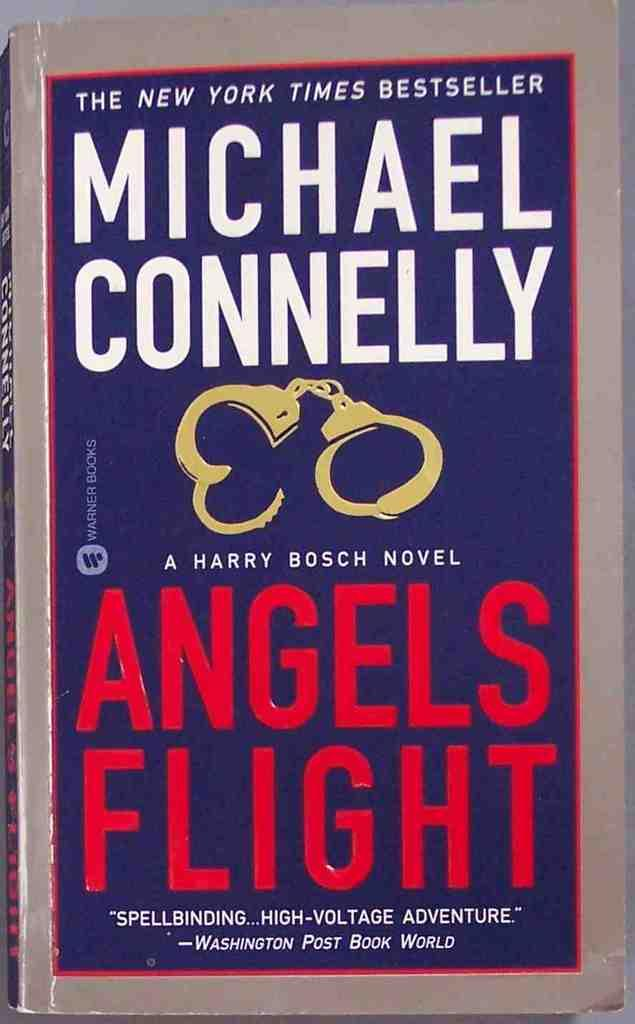<image>
Write a terse but informative summary of the picture. The book Angels Flight has a pair of golden handcuffs on the cover. 